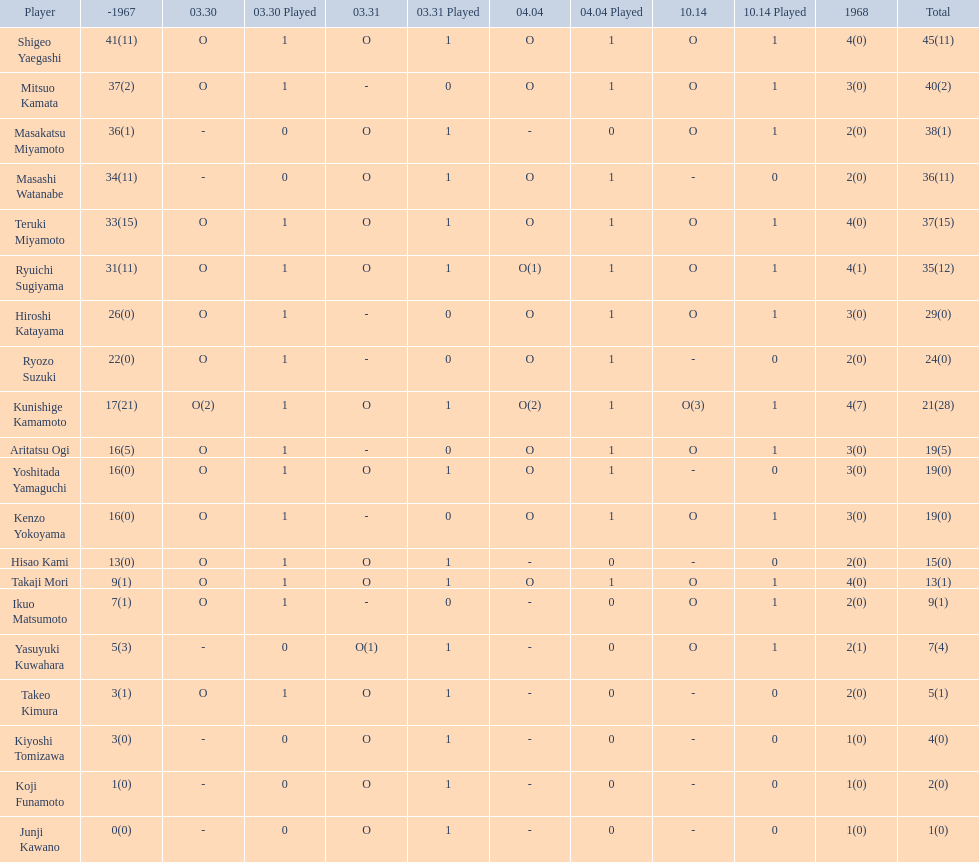How many points did takaji mori have? 13(1). And how many points did junji kawano have? 1(0). To who does the higher of these belong to? Takaji Mori. 